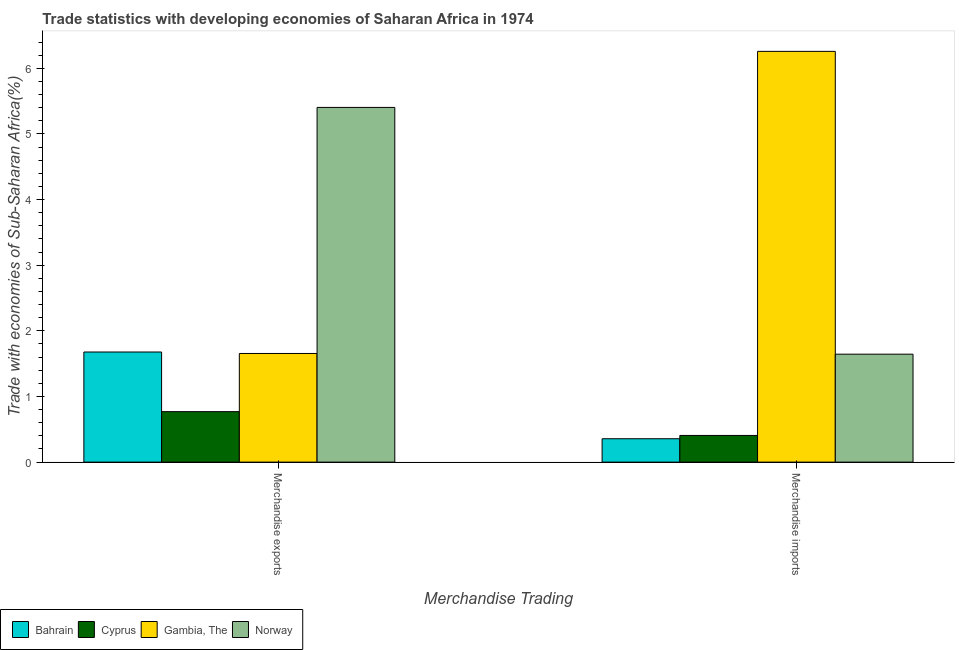How many different coloured bars are there?
Keep it short and to the point. 4. How many groups of bars are there?
Offer a very short reply. 2. Are the number of bars per tick equal to the number of legend labels?
Your answer should be very brief. Yes. How many bars are there on the 1st tick from the left?
Offer a terse response. 4. How many bars are there on the 1st tick from the right?
Your response must be concise. 4. What is the label of the 2nd group of bars from the left?
Offer a terse response. Merchandise imports. What is the merchandise imports in Gambia, The?
Make the answer very short. 6.26. Across all countries, what is the maximum merchandise exports?
Give a very brief answer. 5.4. Across all countries, what is the minimum merchandise imports?
Provide a succinct answer. 0.36. In which country was the merchandise exports maximum?
Provide a short and direct response. Norway. In which country was the merchandise exports minimum?
Ensure brevity in your answer.  Cyprus. What is the total merchandise exports in the graph?
Your answer should be very brief. 9.51. What is the difference between the merchandise exports in Bahrain and that in Gambia, The?
Make the answer very short. 0.02. What is the difference between the merchandise imports in Norway and the merchandise exports in Cyprus?
Offer a very short reply. 0.88. What is the average merchandise exports per country?
Keep it short and to the point. 2.38. What is the difference between the merchandise exports and merchandise imports in Cyprus?
Your answer should be compact. 0.36. What is the ratio of the merchandise imports in Norway to that in Cyprus?
Your response must be concise. 4.05. In how many countries, is the merchandise exports greater than the average merchandise exports taken over all countries?
Ensure brevity in your answer.  1. What does the 1st bar from the left in Merchandise exports represents?
Offer a terse response. Bahrain. What does the 1st bar from the right in Merchandise exports represents?
Your answer should be compact. Norway. What is the difference between two consecutive major ticks on the Y-axis?
Offer a very short reply. 1. Does the graph contain any zero values?
Your answer should be compact. No. How many legend labels are there?
Offer a very short reply. 4. How are the legend labels stacked?
Your answer should be compact. Horizontal. What is the title of the graph?
Provide a short and direct response. Trade statistics with developing economies of Saharan Africa in 1974. What is the label or title of the X-axis?
Make the answer very short. Merchandise Trading. What is the label or title of the Y-axis?
Your answer should be very brief. Trade with economies of Sub-Saharan Africa(%). What is the Trade with economies of Sub-Saharan Africa(%) of Bahrain in Merchandise exports?
Keep it short and to the point. 1.68. What is the Trade with economies of Sub-Saharan Africa(%) in Cyprus in Merchandise exports?
Offer a very short reply. 0.77. What is the Trade with economies of Sub-Saharan Africa(%) in Gambia, The in Merchandise exports?
Offer a terse response. 1.66. What is the Trade with economies of Sub-Saharan Africa(%) of Norway in Merchandise exports?
Make the answer very short. 5.4. What is the Trade with economies of Sub-Saharan Africa(%) of Bahrain in Merchandise imports?
Give a very brief answer. 0.36. What is the Trade with economies of Sub-Saharan Africa(%) in Cyprus in Merchandise imports?
Make the answer very short. 0.41. What is the Trade with economies of Sub-Saharan Africa(%) of Gambia, The in Merchandise imports?
Provide a succinct answer. 6.26. What is the Trade with economies of Sub-Saharan Africa(%) in Norway in Merchandise imports?
Provide a short and direct response. 1.64. Across all Merchandise Trading, what is the maximum Trade with economies of Sub-Saharan Africa(%) in Bahrain?
Make the answer very short. 1.68. Across all Merchandise Trading, what is the maximum Trade with economies of Sub-Saharan Africa(%) in Cyprus?
Make the answer very short. 0.77. Across all Merchandise Trading, what is the maximum Trade with economies of Sub-Saharan Africa(%) of Gambia, The?
Provide a short and direct response. 6.26. Across all Merchandise Trading, what is the maximum Trade with economies of Sub-Saharan Africa(%) of Norway?
Provide a succinct answer. 5.4. Across all Merchandise Trading, what is the minimum Trade with economies of Sub-Saharan Africa(%) in Bahrain?
Offer a terse response. 0.36. Across all Merchandise Trading, what is the minimum Trade with economies of Sub-Saharan Africa(%) of Cyprus?
Your answer should be very brief. 0.41. Across all Merchandise Trading, what is the minimum Trade with economies of Sub-Saharan Africa(%) in Gambia, The?
Ensure brevity in your answer.  1.66. Across all Merchandise Trading, what is the minimum Trade with economies of Sub-Saharan Africa(%) of Norway?
Offer a terse response. 1.64. What is the total Trade with economies of Sub-Saharan Africa(%) of Bahrain in the graph?
Your answer should be compact. 2.03. What is the total Trade with economies of Sub-Saharan Africa(%) of Cyprus in the graph?
Your response must be concise. 1.18. What is the total Trade with economies of Sub-Saharan Africa(%) of Gambia, The in the graph?
Make the answer very short. 7.91. What is the total Trade with economies of Sub-Saharan Africa(%) in Norway in the graph?
Your answer should be very brief. 7.05. What is the difference between the Trade with economies of Sub-Saharan Africa(%) of Bahrain in Merchandise exports and that in Merchandise imports?
Your answer should be very brief. 1.32. What is the difference between the Trade with economies of Sub-Saharan Africa(%) of Cyprus in Merchandise exports and that in Merchandise imports?
Your response must be concise. 0.36. What is the difference between the Trade with economies of Sub-Saharan Africa(%) in Gambia, The in Merchandise exports and that in Merchandise imports?
Your answer should be compact. -4.6. What is the difference between the Trade with economies of Sub-Saharan Africa(%) of Norway in Merchandise exports and that in Merchandise imports?
Give a very brief answer. 3.76. What is the difference between the Trade with economies of Sub-Saharan Africa(%) in Bahrain in Merchandise exports and the Trade with economies of Sub-Saharan Africa(%) in Cyprus in Merchandise imports?
Ensure brevity in your answer.  1.27. What is the difference between the Trade with economies of Sub-Saharan Africa(%) in Bahrain in Merchandise exports and the Trade with economies of Sub-Saharan Africa(%) in Gambia, The in Merchandise imports?
Keep it short and to the point. -4.58. What is the difference between the Trade with economies of Sub-Saharan Africa(%) in Bahrain in Merchandise exports and the Trade with economies of Sub-Saharan Africa(%) in Norway in Merchandise imports?
Your response must be concise. 0.03. What is the difference between the Trade with economies of Sub-Saharan Africa(%) of Cyprus in Merchandise exports and the Trade with economies of Sub-Saharan Africa(%) of Gambia, The in Merchandise imports?
Your answer should be very brief. -5.49. What is the difference between the Trade with economies of Sub-Saharan Africa(%) of Cyprus in Merchandise exports and the Trade with economies of Sub-Saharan Africa(%) of Norway in Merchandise imports?
Your answer should be very brief. -0.88. What is the difference between the Trade with economies of Sub-Saharan Africa(%) of Gambia, The in Merchandise exports and the Trade with economies of Sub-Saharan Africa(%) of Norway in Merchandise imports?
Give a very brief answer. 0.01. What is the average Trade with economies of Sub-Saharan Africa(%) of Bahrain per Merchandise Trading?
Offer a terse response. 1.02. What is the average Trade with economies of Sub-Saharan Africa(%) of Cyprus per Merchandise Trading?
Your answer should be very brief. 0.59. What is the average Trade with economies of Sub-Saharan Africa(%) of Gambia, The per Merchandise Trading?
Provide a short and direct response. 3.96. What is the average Trade with economies of Sub-Saharan Africa(%) in Norway per Merchandise Trading?
Your answer should be very brief. 3.52. What is the difference between the Trade with economies of Sub-Saharan Africa(%) in Bahrain and Trade with economies of Sub-Saharan Africa(%) in Cyprus in Merchandise exports?
Your answer should be very brief. 0.91. What is the difference between the Trade with economies of Sub-Saharan Africa(%) of Bahrain and Trade with economies of Sub-Saharan Africa(%) of Gambia, The in Merchandise exports?
Offer a terse response. 0.02. What is the difference between the Trade with economies of Sub-Saharan Africa(%) of Bahrain and Trade with economies of Sub-Saharan Africa(%) of Norway in Merchandise exports?
Your response must be concise. -3.73. What is the difference between the Trade with economies of Sub-Saharan Africa(%) of Cyprus and Trade with economies of Sub-Saharan Africa(%) of Gambia, The in Merchandise exports?
Your response must be concise. -0.89. What is the difference between the Trade with economies of Sub-Saharan Africa(%) in Cyprus and Trade with economies of Sub-Saharan Africa(%) in Norway in Merchandise exports?
Provide a short and direct response. -4.63. What is the difference between the Trade with economies of Sub-Saharan Africa(%) in Gambia, The and Trade with economies of Sub-Saharan Africa(%) in Norway in Merchandise exports?
Provide a short and direct response. -3.75. What is the difference between the Trade with economies of Sub-Saharan Africa(%) in Bahrain and Trade with economies of Sub-Saharan Africa(%) in Cyprus in Merchandise imports?
Provide a short and direct response. -0.05. What is the difference between the Trade with economies of Sub-Saharan Africa(%) in Bahrain and Trade with economies of Sub-Saharan Africa(%) in Gambia, The in Merchandise imports?
Provide a succinct answer. -5.9. What is the difference between the Trade with economies of Sub-Saharan Africa(%) of Bahrain and Trade with economies of Sub-Saharan Africa(%) of Norway in Merchandise imports?
Your response must be concise. -1.29. What is the difference between the Trade with economies of Sub-Saharan Africa(%) of Cyprus and Trade with economies of Sub-Saharan Africa(%) of Gambia, The in Merchandise imports?
Offer a terse response. -5.85. What is the difference between the Trade with economies of Sub-Saharan Africa(%) of Cyprus and Trade with economies of Sub-Saharan Africa(%) of Norway in Merchandise imports?
Keep it short and to the point. -1.24. What is the difference between the Trade with economies of Sub-Saharan Africa(%) in Gambia, The and Trade with economies of Sub-Saharan Africa(%) in Norway in Merchandise imports?
Provide a short and direct response. 4.61. What is the ratio of the Trade with economies of Sub-Saharan Africa(%) of Bahrain in Merchandise exports to that in Merchandise imports?
Your response must be concise. 4.71. What is the ratio of the Trade with economies of Sub-Saharan Africa(%) in Cyprus in Merchandise exports to that in Merchandise imports?
Ensure brevity in your answer.  1.89. What is the ratio of the Trade with economies of Sub-Saharan Africa(%) of Gambia, The in Merchandise exports to that in Merchandise imports?
Give a very brief answer. 0.26. What is the ratio of the Trade with economies of Sub-Saharan Africa(%) in Norway in Merchandise exports to that in Merchandise imports?
Ensure brevity in your answer.  3.29. What is the difference between the highest and the second highest Trade with economies of Sub-Saharan Africa(%) of Bahrain?
Make the answer very short. 1.32. What is the difference between the highest and the second highest Trade with economies of Sub-Saharan Africa(%) in Cyprus?
Your answer should be very brief. 0.36. What is the difference between the highest and the second highest Trade with economies of Sub-Saharan Africa(%) of Gambia, The?
Make the answer very short. 4.6. What is the difference between the highest and the second highest Trade with economies of Sub-Saharan Africa(%) of Norway?
Provide a short and direct response. 3.76. What is the difference between the highest and the lowest Trade with economies of Sub-Saharan Africa(%) in Bahrain?
Give a very brief answer. 1.32. What is the difference between the highest and the lowest Trade with economies of Sub-Saharan Africa(%) of Cyprus?
Give a very brief answer. 0.36. What is the difference between the highest and the lowest Trade with economies of Sub-Saharan Africa(%) of Gambia, The?
Give a very brief answer. 4.6. What is the difference between the highest and the lowest Trade with economies of Sub-Saharan Africa(%) of Norway?
Make the answer very short. 3.76. 